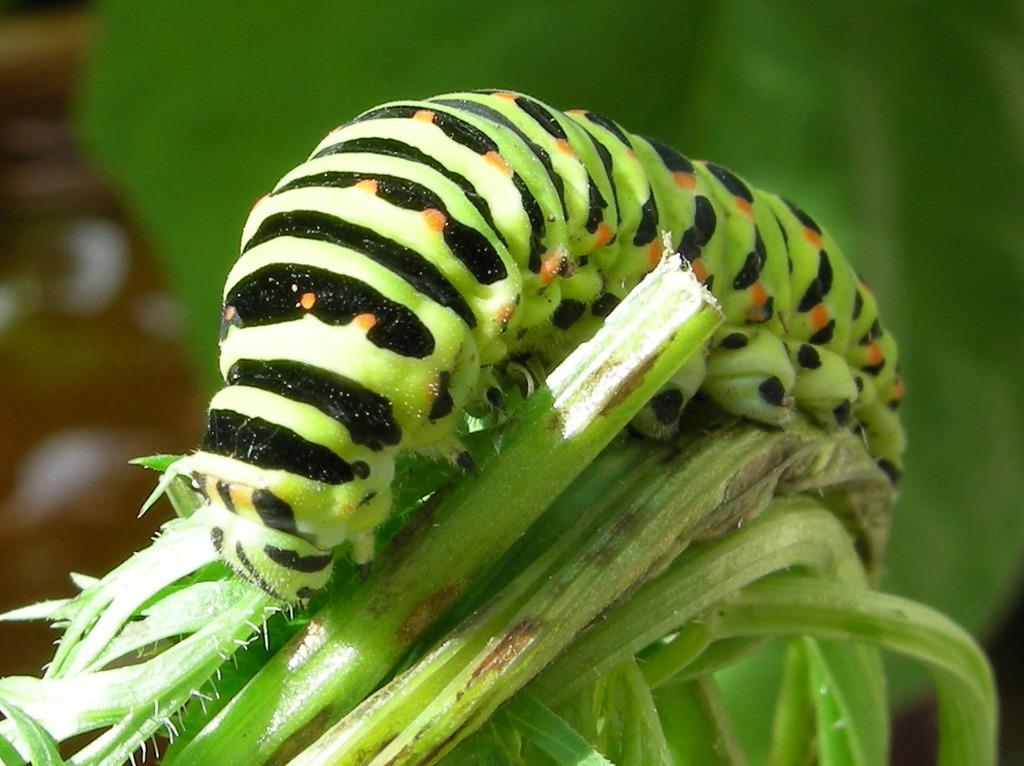What is the main subject of the image? The main subject of the image is a caterpillar. What is the caterpillar doing in the image? The caterpillar is crawling on the grass. What type of quilt is visible in the image? There is no quilt present in the image; it features a caterpillar crawling on the grass. What is the chance of seeing a cloud in the image? The provided facts do not mention any clouds in the image, so it is impossible to determine the chance of seeing one. 